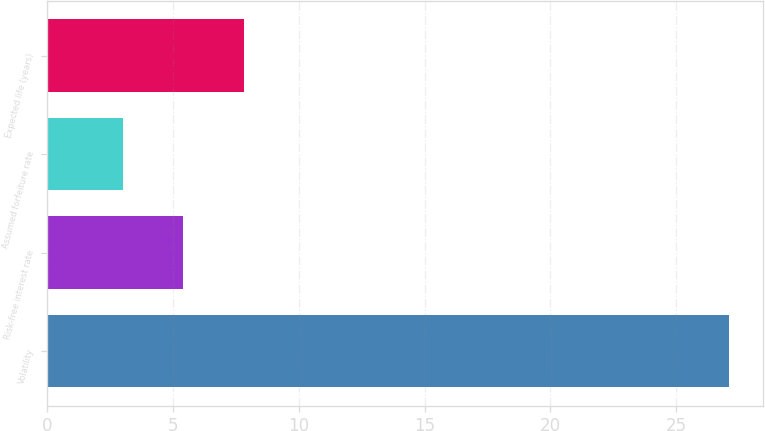Convert chart to OTSL. <chart><loc_0><loc_0><loc_500><loc_500><bar_chart><fcel>Volatility<fcel>Risk-free interest rate<fcel>Assumed forfeiture rate<fcel>Expected life (years)<nl><fcel>27.1<fcel>5.41<fcel>3<fcel>7.82<nl></chart> 